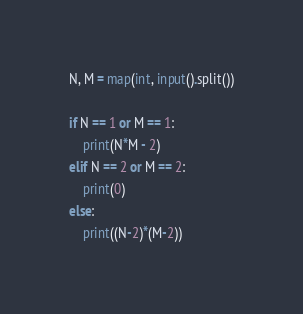<code> <loc_0><loc_0><loc_500><loc_500><_Python_>N, M = map(int, input().split())

if N == 1 or M == 1:
    print(N*M - 2)
elif N == 2 or M == 2:
    print(0)
else:
    print((N-2)*(M-2))</code> 